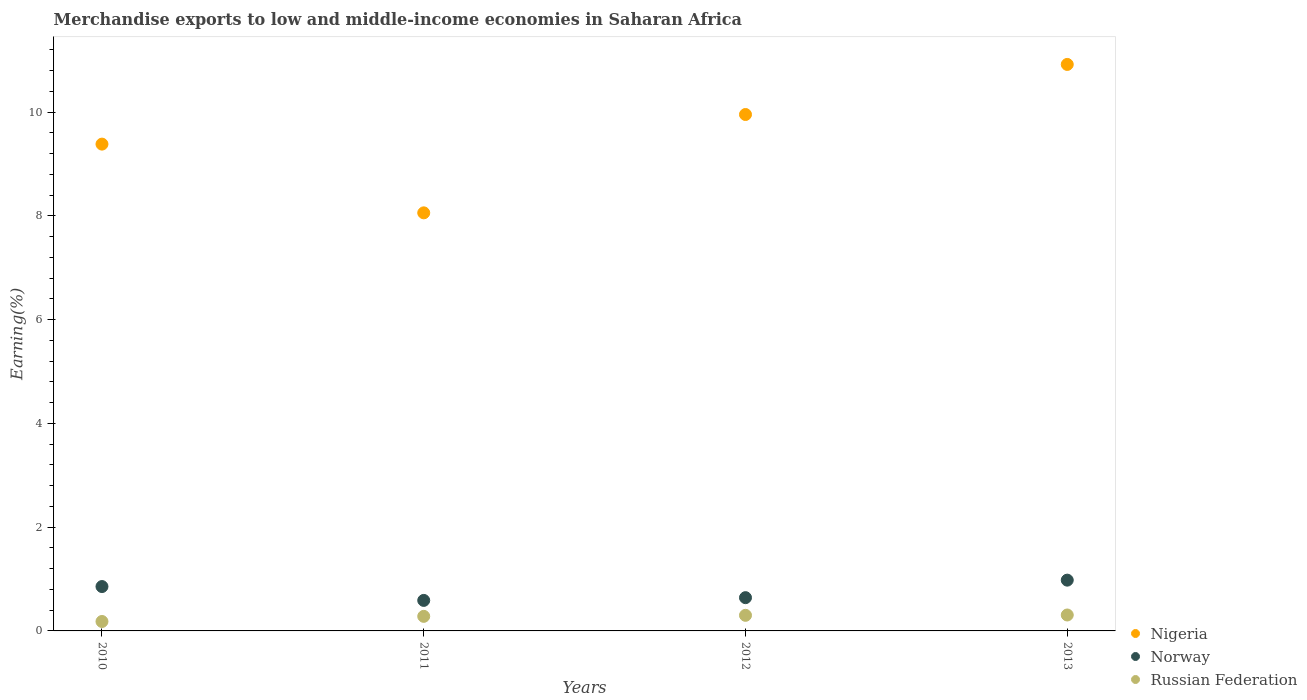How many different coloured dotlines are there?
Make the answer very short. 3. What is the percentage of amount earned from merchandise exports in Norway in 2012?
Offer a very short reply. 0.64. Across all years, what is the maximum percentage of amount earned from merchandise exports in Nigeria?
Make the answer very short. 10.92. Across all years, what is the minimum percentage of amount earned from merchandise exports in Nigeria?
Give a very brief answer. 8.06. In which year was the percentage of amount earned from merchandise exports in Norway maximum?
Make the answer very short. 2013. What is the total percentage of amount earned from merchandise exports in Nigeria in the graph?
Give a very brief answer. 38.31. What is the difference between the percentage of amount earned from merchandise exports in Nigeria in 2010 and that in 2012?
Keep it short and to the point. -0.57. What is the difference between the percentage of amount earned from merchandise exports in Nigeria in 2011 and the percentage of amount earned from merchandise exports in Norway in 2010?
Your response must be concise. 7.2. What is the average percentage of amount earned from merchandise exports in Norway per year?
Offer a very short reply. 0.77. In the year 2010, what is the difference between the percentage of amount earned from merchandise exports in Nigeria and percentage of amount earned from merchandise exports in Russian Federation?
Keep it short and to the point. 9.2. In how many years, is the percentage of amount earned from merchandise exports in Russian Federation greater than 0.4 %?
Give a very brief answer. 0. What is the ratio of the percentage of amount earned from merchandise exports in Nigeria in 2011 to that in 2012?
Offer a very short reply. 0.81. Is the percentage of amount earned from merchandise exports in Norway in 2012 less than that in 2013?
Offer a terse response. Yes. Is the difference between the percentage of amount earned from merchandise exports in Nigeria in 2010 and 2013 greater than the difference between the percentage of amount earned from merchandise exports in Russian Federation in 2010 and 2013?
Make the answer very short. No. What is the difference between the highest and the second highest percentage of amount earned from merchandise exports in Norway?
Your answer should be compact. 0.12. What is the difference between the highest and the lowest percentage of amount earned from merchandise exports in Norway?
Give a very brief answer. 0.39. Is the sum of the percentage of amount earned from merchandise exports in Nigeria in 2011 and 2013 greater than the maximum percentage of amount earned from merchandise exports in Norway across all years?
Provide a short and direct response. Yes. How many years are there in the graph?
Provide a succinct answer. 4. Are the values on the major ticks of Y-axis written in scientific E-notation?
Offer a very short reply. No. Where does the legend appear in the graph?
Make the answer very short. Bottom right. How are the legend labels stacked?
Offer a very short reply. Vertical. What is the title of the graph?
Ensure brevity in your answer.  Merchandise exports to low and middle-income economies in Saharan Africa. What is the label or title of the Y-axis?
Make the answer very short. Earning(%). What is the Earning(%) in Nigeria in 2010?
Give a very brief answer. 9.38. What is the Earning(%) of Norway in 2010?
Your response must be concise. 0.86. What is the Earning(%) in Russian Federation in 2010?
Your answer should be very brief. 0.18. What is the Earning(%) in Nigeria in 2011?
Make the answer very short. 8.06. What is the Earning(%) of Norway in 2011?
Make the answer very short. 0.59. What is the Earning(%) in Russian Federation in 2011?
Offer a terse response. 0.28. What is the Earning(%) of Nigeria in 2012?
Ensure brevity in your answer.  9.95. What is the Earning(%) of Norway in 2012?
Offer a terse response. 0.64. What is the Earning(%) of Russian Federation in 2012?
Ensure brevity in your answer.  0.3. What is the Earning(%) of Nigeria in 2013?
Your response must be concise. 10.92. What is the Earning(%) of Norway in 2013?
Your answer should be very brief. 0.98. What is the Earning(%) in Russian Federation in 2013?
Offer a terse response. 0.31. Across all years, what is the maximum Earning(%) in Nigeria?
Give a very brief answer. 10.92. Across all years, what is the maximum Earning(%) of Norway?
Offer a very short reply. 0.98. Across all years, what is the maximum Earning(%) in Russian Federation?
Keep it short and to the point. 0.31. Across all years, what is the minimum Earning(%) of Nigeria?
Provide a short and direct response. 8.06. Across all years, what is the minimum Earning(%) in Norway?
Your answer should be very brief. 0.59. Across all years, what is the minimum Earning(%) of Russian Federation?
Provide a succinct answer. 0.18. What is the total Earning(%) in Nigeria in the graph?
Make the answer very short. 38.31. What is the total Earning(%) in Norway in the graph?
Offer a terse response. 3.06. What is the total Earning(%) in Russian Federation in the graph?
Keep it short and to the point. 1.07. What is the difference between the Earning(%) in Nigeria in 2010 and that in 2011?
Make the answer very short. 1.32. What is the difference between the Earning(%) in Norway in 2010 and that in 2011?
Offer a terse response. 0.27. What is the difference between the Earning(%) of Russian Federation in 2010 and that in 2011?
Your response must be concise. -0.1. What is the difference between the Earning(%) in Nigeria in 2010 and that in 2012?
Your answer should be very brief. -0.57. What is the difference between the Earning(%) of Norway in 2010 and that in 2012?
Your answer should be very brief. 0.21. What is the difference between the Earning(%) in Russian Federation in 2010 and that in 2012?
Ensure brevity in your answer.  -0.12. What is the difference between the Earning(%) of Nigeria in 2010 and that in 2013?
Provide a short and direct response. -1.54. What is the difference between the Earning(%) of Norway in 2010 and that in 2013?
Provide a short and direct response. -0.12. What is the difference between the Earning(%) in Russian Federation in 2010 and that in 2013?
Ensure brevity in your answer.  -0.13. What is the difference between the Earning(%) in Nigeria in 2011 and that in 2012?
Ensure brevity in your answer.  -1.9. What is the difference between the Earning(%) in Norway in 2011 and that in 2012?
Give a very brief answer. -0.05. What is the difference between the Earning(%) of Russian Federation in 2011 and that in 2012?
Give a very brief answer. -0.02. What is the difference between the Earning(%) of Nigeria in 2011 and that in 2013?
Your response must be concise. -2.86. What is the difference between the Earning(%) in Norway in 2011 and that in 2013?
Your answer should be compact. -0.39. What is the difference between the Earning(%) of Russian Federation in 2011 and that in 2013?
Your response must be concise. -0.03. What is the difference between the Earning(%) of Nigeria in 2012 and that in 2013?
Your response must be concise. -0.96. What is the difference between the Earning(%) in Norway in 2012 and that in 2013?
Ensure brevity in your answer.  -0.34. What is the difference between the Earning(%) in Russian Federation in 2012 and that in 2013?
Your answer should be compact. -0.01. What is the difference between the Earning(%) of Nigeria in 2010 and the Earning(%) of Norway in 2011?
Keep it short and to the point. 8.79. What is the difference between the Earning(%) of Nigeria in 2010 and the Earning(%) of Russian Federation in 2011?
Keep it short and to the point. 9.1. What is the difference between the Earning(%) in Norway in 2010 and the Earning(%) in Russian Federation in 2011?
Your answer should be compact. 0.57. What is the difference between the Earning(%) of Nigeria in 2010 and the Earning(%) of Norway in 2012?
Provide a short and direct response. 8.74. What is the difference between the Earning(%) in Nigeria in 2010 and the Earning(%) in Russian Federation in 2012?
Give a very brief answer. 9.08. What is the difference between the Earning(%) in Norway in 2010 and the Earning(%) in Russian Federation in 2012?
Make the answer very short. 0.55. What is the difference between the Earning(%) in Nigeria in 2010 and the Earning(%) in Norway in 2013?
Your answer should be very brief. 8.4. What is the difference between the Earning(%) of Nigeria in 2010 and the Earning(%) of Russian Federation in 2013?
Provide a short and direct response. 9.07. What is the difference between the Earning(%) in Norway in 2010 and the Earning(%) in Russian Federation in 2013?
Keep it short and to the point. 0.55. What is the difference between the Earning(%) of Nigeria in 2011 and the Earning(%) of Norway in 2012?
Provide a succinct answer. 7.42. What is the difference between the Earning(%) of Nigeria in 2011 and the Earning(%) of Russian Federation in 2012?
Provide a short and direct response. 7.76. What is the difference between the Earning(%) in Norway in 2011 and the Earning(%) in Russian Federation in 2012?
Your response must be concise. 0.29. What is the difference between the Earning(%) of Nigeria in 2011 and the Earning(%) of Norway in 2013?
Keep it short and to the point. 7.08. What is the difference between the Earning(%) in Nigeria in 2011 and the Earning(%) in Russian Federation in 2013?
Offer a terse response. 7.75. What is the difference between the Earning(%) in Norway in 2011 and the Earning(%) in Russian Federation in 2013?
Your answer should be compact. 0.28. What is the difference between the Earning(%) of Nigeria in 2012 and the Earning(%) of Norway in 2013?
Make the answer very short. 8.97. What is the difference between the Earning(%) in Nigeria in 2012 and the Earning(%) in Russian Federation in 2013?
Your answer should be very brief. 9.64. What is the difference between the Earning(%) in Norway in 2012 and the Earning(%) in Russian Federation in 2013?
Ensure brevity in your answer.  0.33. What is the average Earning(%) of Nigeria per year?
Your answer should be very brief. 9.58. What is the average Earning(%) of Norway per year?
Keep it short and to the point. 0.77. What is the average Earning(%) in Russian Federation per year?
Your response must be concise. 0.27. In the year 2010, what is the difference between the Earning(%) of Nigeria and Earning(%) of Norway?
Offer a terse response. 8.53. In the year 2010, what is the difference between the Earning(%) in Nigeria and Earning(%) in Russian Federation?
Your answer should be very brief. 9.2. In the year 2010, what is the difference between the Earning(%) in Norway and Earning(%) in Russian Federation?
Give a very brief answer. 0.67. In the year 2011, what is the difference between the Earning(%) of Nigeria and Earning(%) of Norway?
Your answer should be compact. 7.47. In the year 2011, what is the difference between the Earning(%) in Nigeria and Earning(%) in Russian Federation?
Offer a very short reply. 7.78. In the year 2011, what is the difference between the Earning(%) in Norway and Earning(%) in Russian Federation?
Your answer should be compact. 0.31. In the year 2012, what is the difference between the Earning(%) of Nigeria and Earning(%) of Norway?
Your answer should be compact. 9.31. In the year 2012, what is the difference between the Earning(%) in Nigeria and Earning(%) in Russian Federation?
Ensure brevity in your answer.  9.65. In the year 2012, what is the difference between the Earning(%) of Norway and Earning(%) of Russian Federation?
Provide a short and direct response. 0.34. In the year 2013, what is the difference between the Earning(%) of Nigeria and Earning(%) of Norway?
Your answer should be very brief. 9.94. In the year 2013, what is the difference between the Earning(%) in Nigeria and Earning(%) in Russian Federation?
Your response must be concise. 10.61. In the year 2013, what is the difference between the Earning(%) in Norway and Earning(%) in Russian Federation?
Give a very brief answer. 0.67. What is the ratio of the Earning(%) of Nigeria in 2010 to that in 2011?
Ensure brevity in your answer.  1.16. What is the ratio of the Earning(%) in Norway in 2010 to that in 2011?
Keep it short and to the point. 1.45. What is the ratio of the Earning(%) of Russian Federation in 2010 to that in 2011?
Ensure brevity in your answer.  0.65. What is the ratio of the Earning(%) in Nigeria in 2010 to that in 2012?
Ensure brevity in your answer.  0.94. What is the ratio of the Earning(%) of Norway in 2010 to that in 2012?
Your response must be concise. 1.33. What is the ratio of the Earning(%) in Russian Federation in 2010 to that in 2012?
Provide a succinct answer. 0.6. What is the ratio of the Earning(%) in Nigeria in 2010 to that in 2013?
Provide a succinct answer. 0.86. What is the ratio of the Earning(%) in Norway in 2010 to that in 2013?
Provide a succinct answer. 0.87. What is the ratio of the Earning(%) in Russian Federation in 2010 to that in 2013?
Provide a short and direct response. 0.59. What is the ratio of the Earning(%) of Nigeria in 2011 to that in 2012?
Give a very brief answer. 0.81. What is the ratio of the Earning(%) of Norway in 2011 to that in 2012?
Your answer should be compact. 0.92. What is the ratio of the Earning(%) of Russian Federation in 2011 to that in 2012?
Give a very brief answer. 0.93. What is the ratio of the Earning(%) in Nigeria in 2011 to that in 2013?
Make the answer very short. 0.74. What is the ratio of the Earning(%) in Norway in 2011 to that in 2013?
Keep it short and to the point. 0.6. What is the ratio of the Earning(%) in Russian Federation in 2011 to that in 2013?
Provide a succinct answer. 0.91. What is the ratio of the Earning(%) in Nigeria in 2012 to that in 2013?
Provide a short and direct response. 0.91. What is the ratio of the Earning(%) of Norway in 2012 to that in 2013?
Keep it short and to the point. 0.66. What is the ratio of the Earning(%) in Russian Federation in 2012 to that in 2013?
Offer a terse response. 0.98. What is the difference between the highest and the second highest Earning(%) of Nigeria?
Give a very brief answer. 0.96. What is the difference between the highest and the second highest Earning(%) of Norway?
Provide a short and direct response. 0.12. What is the difference between the highest and the second highest Earning(%) of Russian Federation?
Provide a short and direct response. 0.01. What is the difference between the highest and the lowest Earning(%) of Nigeria?
Provide a succinct answer. 2.86. What is the difference between the highest and the lowest Earning(%) of Norway?
Keep it short and to the point. 0.39. What is the difference between the highest and the lowest Earning(%) of Russian Federation?
Your answer should be compact. 0.13. 